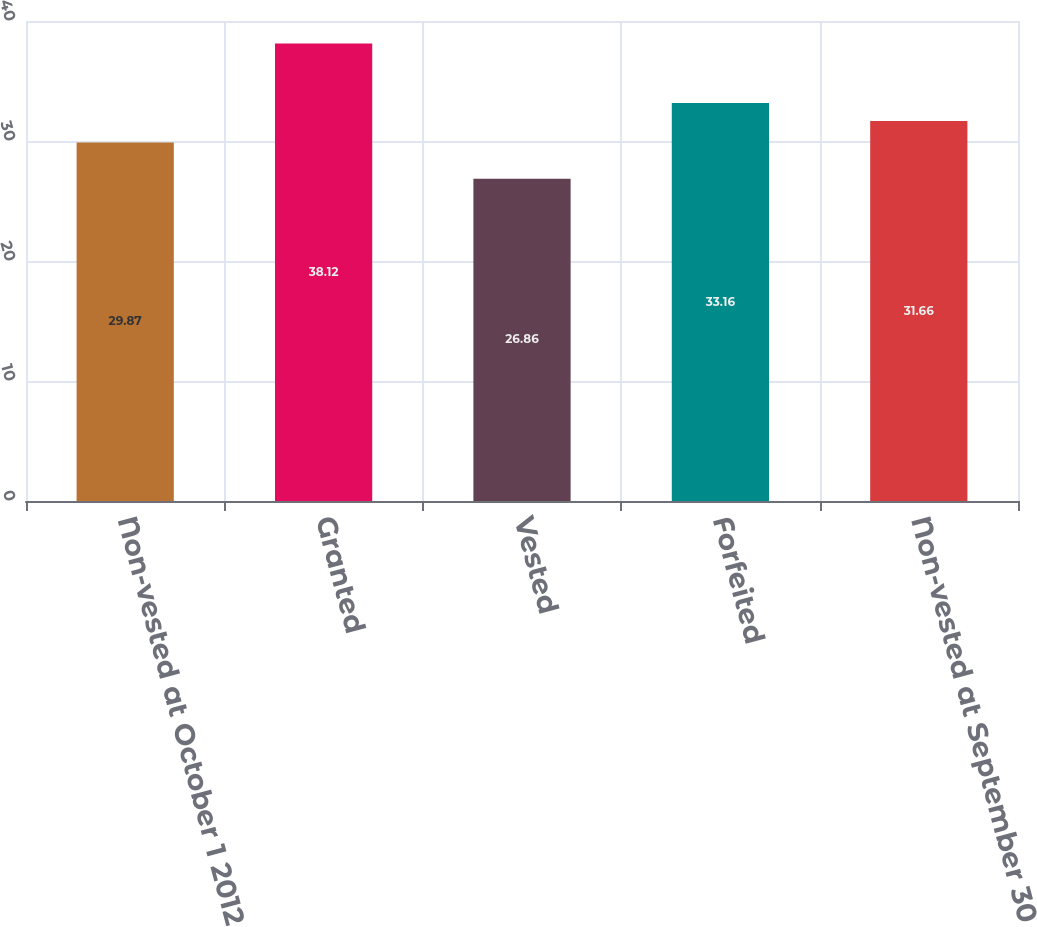<chart> <loc_0><loc_0><loc_500><loc_500><bar_chart><fcel>Non-vested at October 1 2012<fcel>Granted<fcel>Vested<fcel>Forfeited<fcel>Non-vested at September 30<nl><fcel>29.87<fcel>38.12<fcel>26.86<fcel>33.16<fcel>31.66<nl></chart> 